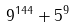<formula> <loc_0><loc_0><loc_500><loc_500>9 ^ { 1 4 4 } + 5 ^ { 9 }</formula> 